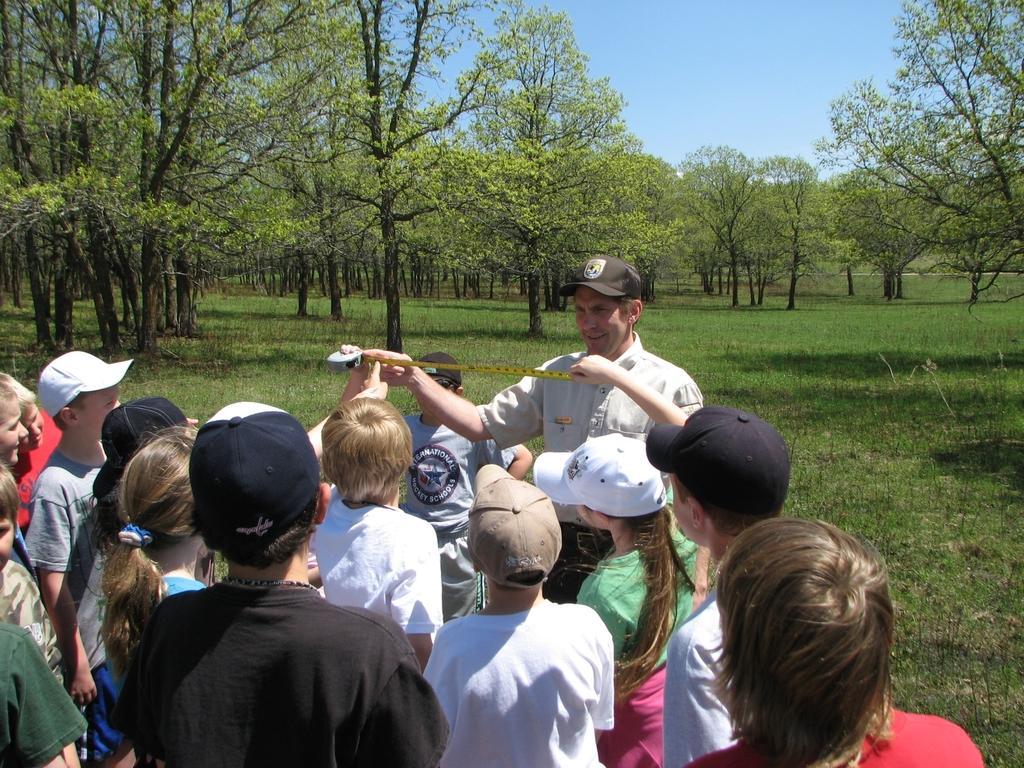Could you give a brief overview of what you see in this image? In this picture there are people standing, among them few people holding measuring tape and we can see grass and trees. In the background of the image we can see the sky. 